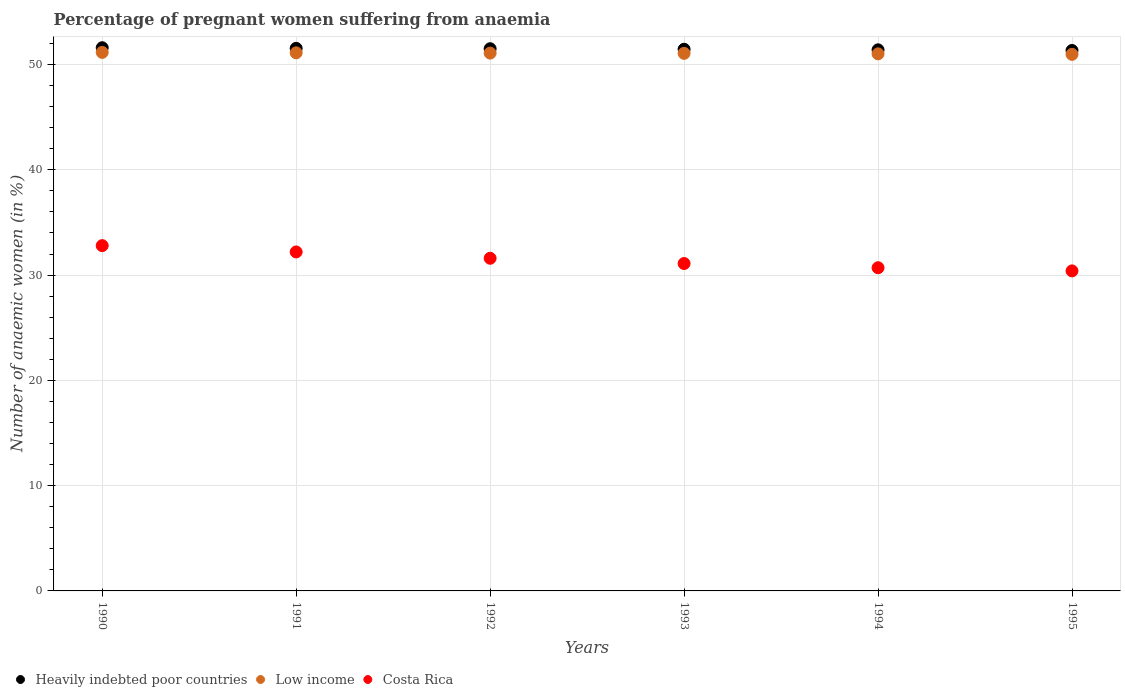How many different coloured dotlines are there?
Provide a short and direct response. 3. Is the number of dotlines equal to the number of legend labels?
Keep it short and to the point. Yes. What is the number of anaemic women in Low income in 1994?
Your answer should be very brief. 51.02. Across all years, what is the maximum number of anaemic women in Low income?
Offer a very short reply. 51.16. Across all years, what is the minimum number of anaemic women in Costa Rica?
Offer a terse response. 30.4. In which year was the number of anaemic women in Heavily indebted poor countries minimum?
Make the answer very short. 1995. What is the total number of anaemic women in Low income in the graph?
Ensure brevity in your answer.  306.41. What is the difference between the number of anaemic women in Heavily indebted poor countries in 1993 and that in 1995?
Offer a terse response. 0.12. What is the difference between the number of anaemic women in Heavily indebted poor countries in 1992 and the number of anaemic women in Costa Rica in 1990?
Give a very brief answer. 18.71. What is the average number of anaemic women in Low income per year?
Give a very brief answer. 51.07. In the year 1995, what is the difference between the number of anaemic women in Costa Rica and number of anaemic women in Heavily indebted poor countries?
Offer a terse response. -20.94. What is the ratio of the number of anaemic women in Heavily indebted poor countries in 1991 to that in 1992?
Your response must be concise. 1. Is the difference between the number of anaemic women in Costa Rica in 1991 and 1992 greater than the difference between the number of anaemic women in Heavily indebted poor countries in 1991 and 1992?
Ensure brevity in your answer.  Yes. What is the difference between the highest and the second highest number of anaemic women in Heavily indebted poor countries?
Ensure brevity in your answer.  0.06. What is the difference between the highest and the lowest number of anaemic women in Low income?
Offer a very short reply. 0.19. Is the sum of the number of anaemic women in Heavily indebted poor countries in 1990 and 1991 greater than the maximum number of anaemic women in Costa Rica across all years?
Make the answer very short. Yes. Is it the case that in every year, the sum of the number of anaemic women in Low income and number of anaemic women in Costa Rica  is greater than the number of anaemic women in Heavily indebted poor countries?
Offer a terse response. Yes. Does the number of anaemic women in Heavily indebted poor countries monotonically increase over the years?
Provide a succinct answer. No. What is the difference between two consecutive major ticks on the Y-axis?
Offer a terse response. 10. Are the values on the major ticks of Y-axis written in scientific E-notation?
Provide a short and direct response. No. How are the legend labels stacked?
Offer a very short reply. Horizontal. What is the title of the graph?
Provide a succinct answer. Percentage of pregnant women suffering from anaemia. Does "Cyprus" appear as one of the legend labels in the graph?
Your answer should be very brief. No. What is the label or title of the Y-axis?
Give a very brief answer. Number of anaemic women (in %). What is the Number of anaemic women (in %) of Heavily indebted poor countries in 1990?
Offer a very short reply. 51.6. What is the Number of anaemic women (in %) of Low income in 1990?
Provide a short and direct response. 51.16. What is the Number of anaemic women (in %) of Costa Rica in 1990?
Ensure brevity in your answer.  32.8. What is the Number of anaemic women (in %) of Heavily indebted poor countries in 1991?
Keep it short and to the point. 51.54. What is the Number of anaemic women (in %) of Low income in 1991?
Your response must be concise. 51.12. What is the Number of anaemic women (in %) in Costa Rica in 1991?
Your response must be concise. 32.2. What is the Number of anaemic women (in %) in Heavily indebted poor countries in 1992?
Make the answer very short. 51.51. What is the Number of anaemic women (in %) of Low income in 1992?
Your answer should be compact. 51.09. What is the Number of anaemic women (in %) of Costa Rica in 1992?
Your answer should be compact. 31.6. What is the Number of anaemic women (in %) of Heavily indebted poor countries in 1993?
Your answer should be very brief. 51.46. What is the Number of anaemic women (in %) in Low income in 1993?
Your answer should be very brief. 51.06. What is the Number of anaemic women (in %) in Costa Rica in 1993?
Provide a short and direct response. 31.1. What is the Number of anaemic women (in %) of Heavily indebted poor countries in 1994?
Ensure brevity in your answer.  51.4. What is the Number of anaemic women (in %) in Low income in 1994?
Offer a very short reply. 51.02. What is the Number of anaemic women (in %) of Costa Rica in 1994?
Give a very brief answer. 30.7. What is the Number of anaemic women (in %) of Heavily indebted poor countries in 1995?
Your answer should be very brief. 51.34. What is the Number of anaemic women (in %) of Low income in 1995?
Ensure brevity in your answer.  50.97. What is the Number of anaemic women (in %) in Costa Rica in 1995?
Your response must be concise. 30.4. Across all years, what is the maximum Number of anaemic women (in %) of Heavily indebted poor countries?
Ensure brevity in your answer.  51.6. Across all years, what is the maximum Number of anaemic women (in %) in Low income?
Make the answer very short. 51.16. Across all years, what is the maximum Number of anaemic women (in %) in Costa Rica?
Provide a succinct answer. 32.8. Across all years, what is the minimum Number of anaemic women (in %) in Heavily indebted poor countries?
Offer a very short reply. 51.34. Across all years, what is the minimum Number of anaemic women (in %) of Low income?
Give a very brief answer. 50.97. Across all years, what is the minimum Number of anaemic women (in %) in Costa Rica?
Give a very brief answer. 30.4. What is the total Number of anaemic women (in %) of Heavily indebted poor countries in the graph?
Your answer should be very brief. 308.84. What is the total Number of anaemic women (in %) in Low income in the graph?
Provide a succinct answer. 306.41. What is the total Number of anaemic women (in %) in Costa Rica in the graph?
Your response must be concise. 188.8. What is the difference between the Number of anaemic women (in %) in Heavily indebted poor countries in 1990 and that in 1991?
Provide a succinct answer. 0.06. What is the difference between the Number of anaemic women (in %) in Low income in 1990 and that in 1991?
Ensure brevity in your answer.  0.04. What is the difference between the Number of anaemic women (in %) of Heavily indebted poor countries in 1990 and that in 1992?
Offer a very short reply. 0.09. What is the difference between the Number of anaemic women (in %) in Low income in 1990 and that in 1992?
Your response must be concise. 0.07. What is the difference between the Number of anaemic women (in %) of Heavily indebted poor countries in 1990 and that in 1993?
Your answer should be very brief. 0.14. What is the difference between the Number of anaemic women (in %) of Low income in 1990 and that in 1993?
Ensure brevity in your answer.  0.09. What is the difference between the Number of anaemic women (in %) of Costa Rica in 1990 and that in 1993?
Your answer should be compact. 1.7. What is the difference between the Number of anaemic women (in %) in Heavily indebted poor countries in 1990 and that in 1994?
Make the answer very short. 0.2. What is the difference between the Number of anaemic women (in %) of Low income in 1990 and that in 1994?
Your answer should be very brief. 0.14. What is the difference between the Number of anaemic women (in %) in Heavily indebted poor countries in 1990 and that in 1995?
Provide a succinct answer. 0.26. What is the difference between the Number of anaemic women (in %) in Low income in 1990 and that in 1995?
Your answer should be compact. 0.19. What is the difference between the Number of anaemic women (in %) of Costa Rica in 1990 and that in 1995?
Offer a very short reply. 2.4. What is the difference between the Number of anaemic women (in %) in Heavily indebted poor countries in 1991 and that in 1992?
Provide a succinct answer. 0.04. What is the difference between the Number of anaemic women (in %) of Low income in 1991 and that in 1992?
Provide a short and direct response. 0.03. What is the difference between the Number of anaemic women (in %) of Costa Rica in 1991 and that in 1992?
Your answer should be compact. 0.6. What is the difference between the Number of anaemic women (in %) in Heavily indebted poor countries in 1991 and that in 1993?
Your answer should be compact. 0.09. What is the difference between the Number of anaemic women (in %) in Low income in 1991 and that in 1993?
Offer a terse response. 0.05. What is the difference between the Number of anaemic women (in %) in Heavily indebted poor countries in 1991 and that in 1994?
Provide a succinct answer. 0.14. What is the difference between the Number of anaemic women (in %) in Low income in 1991 and that in 1994?
Provide a succinct answer. 0.1. What is the difference between the Number of anaemic women (in %) in Heavily indebted poor countries in 1991 and that in 1995?
Your response must be concise. 0.2. What is the difference between the Number of anaemic women (in %) in Low income in 1991 and that in 1995?
Your answer should be very brief. 0.14. What is the difference between the Number of anaemic women (in %) of Costa Rica in 1991 and that in 1995?
Ensure brevity in your answer.  1.8. What is the difference between the Number of anaemic women (in %) of Heavily indebted poor countries in 1992 and that in 1993?
Keep it short and to the point. 0.05. What is the difference between the Number of anaemic women (in %) of Low income in 1992 and that in 1993?
Offer a terse response. 0.02. What is the difference between the Number of anaemic women (in %) in Heavily indebted poor countries in 1992 and that in 1994?
Keep it short and to the point. 0.11. What is the difference between the Number of anaemic women (in %) in Low income in 1992 and that in 1994?
Your answer should be very brief. 0.07. What is the difference between the Number of anaemic women (in %) in Costa Rica in 1992 and that in 1994?
Offer a very short reply. 0.9. What is the difference between the Number of anaemic women (in %) of Heavily indebted poor countries in 1992 and that in 1995?
Ensure brevity in your answer.  0.17. What is the difference between the Number of anaemic women (in %) of Low income in 1992 and that in 1995?
Make the answer very short. 0.12. What is the difference between the Number of anaemic women (in %) in Costa Rica in 1992 and that in 1995?
Your response must be concise. 1.2. What is the difference between the Number of anaemic women (in %) of Heavily indebted poor countries in 1993 and that in 1994?
Your answer should be compact. 0.06. What is the difference between the Number of anaemic women (in %) in Low income in 1993 and that in 1994?
Keep it short and to the point. 0.05. What is the difference between the Number of anaemic women (in %) in Heavily indebted poor countries in 1993 and that in 1995?
Your answer should be compact. 0.12. What is the difference between the Number of anaemic women (in %) in Low income in 1993 and that in 1995?
Your answer should be compact. 0.09. What is the difference between the Number of anaemic women (in %) of Costa Rica in 1993 and that in 1995?
Keep it short and to the point. 0.7. What is the difference between the Number of anaemic women (in %) of Heavily indebted poor countries in 1994 and that in 1995?
Keep it short and to the point. 0.06. What is the difference between the Number of anaemic women (in %) of Low income in 1994 and that in 1995?
Provide a short and direct response. 0.05. What is the difference between the Number of anaemic women (in %) of Heavily indebted poor countries in 1990 and the Number of anaemic women (in %) of Low income in 1991?
Ensure brevity in your answer.  0.48. What is the difference between the Number of anaemic women (in %) of Heavily indebted poor countries in 1990 and the Number of anaemic women (in %) of Costa Rica in 1991?
Your response must be concise. 19.4. What is the difference between the Number of anaemic women (in %) in Low income in 1990 and the Number of anaemic women (in %) in Costa Rica in 1991?
Keep it short and to the point. 18.96. What is the difference between the Number of anaemic women (in %) in Heavily indebted poor countries in 1990 and the Number of anaemic women (in %) in Low income in 1992?
Make the answer very short. 0.51. What is the difference between the Number of anaemic women (in %) of Heavily indebted poor countries in 1990 and the Number of anaemic women (in %) of Costa Rica in 1992?
Your answer should be very brief. 20. What is the difference between the Number of anaemic women (in %) of Low income in 1990 and the Number of anaemic women (in %) of Costa Rica in 1992?
Provide a short and direct response. 19.56. What is the difference between the Number of anaemic women (in %) of Heavily indebted poor countries in 1990 and the Number of anaemic women (in %) of Low income in 1993?
Your answer should be very brief. 0.53. What is the difference between the Number of anaemic women (in %) of Heavily indebted poor countries in 1990 and the Number of anaemic women (in %) of Costa Rica in 1993?
Keep it short and to the point. 20.5. What is the difference between the Number of anaemic women (in %) in Low income in 1990 and the Number of anaemic women (in %) in Costa Rica in 1993?
Keep it short and to the point. 20.06. What is the difference between the Number of anaemic women (in %) of Heavily indebted poor countries in 1990 and the Number of anaemic women (in %) of Low income in 1994?
Your response must be concise. 0.58. What is the difference between the Number of anaemic women (in %) of Heavily indebted poor countries in 1990 and the Number of anaemic women (in %) of Costa Rica in 1994?
Offer a terse response. 20.9. What is the difference between the Number of anaemic women (in %) of Low income in 1990 and the Number of anaemic women (in %) of Costa Rica in 1994?
Offer a terse response. 20.46. What is the difference between the Number of anaemic women (in %) of Heavily indebted poor countries in 1990 and the Number of anaemic women (in %) of Low income in 1995?
Provide a succinct answer. 0.63. What is the difference between the Number of anaemic women (in %) of Heavily indebted poor countries in 1990 and the Number of anaemic women (in %) of Costa Rica in 1995?
Your answer should be very brief. 21.2. What is the difference between the Number of anaemic women (in %) in Low income in 1990 and the Number of anaemic women (in %) in Costa Rica in 1995?
Provide a succinct answer. 20.76. What is the difference between the Number of anaemic women (in %) of Heavily indebted poor countries in 1991 and the Number of anaemic women (in %) of Low income in 1992?
Your response must be concise. 0.45. What is the difference between the Number of anaemic women (in %) in Heavily indebted poor countries in 1991 and the Number of anaemic women (in %) in Costa Rica in 1992?
Provide a succinct answer. 19.94. What is the difference between the Number of anaemic women (in %) of Low income in 1991 and the Number of anaemic women (in %) of Costa Rica in 1992?
Offer a very short reply. 19.52. What is the difference between the Number of anaemic women (in %) in Heavily indebted poor countries in 1991 and the Number of anaemic women (in %) in Low income in 1993?
Your response must be concise. 0.48. What is the difference between the Number of anaemic women (in %) of Heavily indebted poor countries in 1991 and the Number of anaemic women (in %) of Costa Rica in 1993?
Your answer should be very brief. 20.44. What is the difference between the Number of anaemic women (in %) in Low income in 1991 and the Number of anaemic women (in %) in Costa Rica in 1993?
Offer a terse response. 20.02. What is the difference between the Number of anaemic women (in %) of Heavily indebted poor countries in 1991 and the Number of anaemic women (in %) of Low income in 1994?
Ensure brevity in your answer.  0.52. What is the difference between the Number of anaemic women (in %) in Heavily indebted poor countries in 1991 and the Number of anaemic women (in %) in Costa Rica in 1994?
Offer a terse response. 20.84. What is the difference between the Number of anaemic women (in %) in Low income in 1991 and the Number of anaemic women (in %) in Costa Rica in 1994?
Make the answer very short. 20.42. What is the difference between the Number of anaemic women (in %) of Heavily indebted poor countries in 1991 and the Number of anaemic women (in %) of Low income in 1995?
Your answer should be compact. 0.57. What is the difference between the Number of anaemic women (in %) of Heavily indebted poor countries in 1991 and the Number of anaemic women (in %) of Costa Rica in 1995?
Your answer should be very brief. 21.14. What is the difference between the Number of anaemic women (in %) in Low income in 1991 and the Number of anaemic women (in %) in Costa Rica in 1995?
Make the answer very short. 20.72. What is the difference between the Number of anaemic women (in %) in Heavily indebted poor countries in 1992 and the Number of anaemic women (in %) in Low income in 1993?
Offer a very short reply. 0.44. What is the difference between the Number of anaemic women (in %) in Heavily indebted poor countries in 1992 and the Number of anaemic women (in %) in Costa Rica in 1993?
Offer a very short reply. 20.41. What is the difference between the Number of anaemic women (in %) in Low income in 1992 and the Number of anaemic women (in %) in Costa Rica in 1993?
Your answer should be very brief. 19.99. What is the difference between the Number of anaemic women (in %) of Heavily indebted poor countries in 1992 and the Number of anaemic women (in %) of Low income in 1994?
Your answer should be compact. 0.49. What is the difference between the Number of anaemic women (in %) in Heavily indebted poor countries in 1992 and the Number of anaemic women (in %) in Costa Rica in 1994?
Provide a succinct answer. 20.81. What is the difference between the Number of anaemic women (in %) of Low income in 1992 and the Number of anaemic women (in %) of Costa Rica in 1994?
Your answer should be compact. 20.39. What is the difference between the Number of anaemic women (in %) in Heavily indebted poor countries in 1992 and the Number of anaemic women (in %) in Low income in 1995?
Provide a short and direct response. 0.53. What is the difference between the Number of anaemic women (in %) of Heavily indebted poor countries in 1992 and the Number of anaemic women (in %) of Costa Rica in 1995?
Provide a short and direct response. 21.11. What is the difference between the Number of anaemic women (in %) in Low income in 1992 and the Number of anaemic women (in %) in Costa Rica in 1995?
Keep it short and to the point. 20.69. What is the difference between the Number of anaemic women (in %) of Heavily indebted poor countries in 1993 and the Number of anaemic women (in %) of Low income in 1994?
Ensure brevity in your answer.  0.44. What is the difference between the Number of anaemic women (in %) in Heavily indebted poor countries in 1993 and the Number of anaemic women (in %) in Costa Rica in 1994?
Make the answer very short. 20.76. What is the difference between the Number of anaemic women (in %) in Low income in 1993 and the Number of anaemic women (in %) in Costa Rica in 1994?
Your answer should be very brief. 20.36. What is the difference between the Number of anaemic women (in %) in Heavily indebted poor countries in 1993 and the Number of anaemic women (in %) in Low income in 1995?
Your response must be concise. 0.48. What is the difference between the Number of anaemic women (in %) of Heavily indebted poor countries in 1993 and the Number of anaemic women (in %) of Costa Rica in 1995?
Offer a terse response. 21.06. What is the difference between the Number of anaemic women (in %) of Low income in 1993 and the Number of anaemic women (in %) of Costa Rica in 1995?
Provide a succinct answer. 20.66. What is the difference between the Number of anaemic women (in %) in Heavily indebted poor countries in 1994 and the Number of anaemic women (in %) in Low income in 1995?
Give a very brief answer. 0.43. What is the difference between the Number of anaemic women (in %) in Heavily indebted poor countries in 1994 and the Number of anaemic women (in %) in Costa Rica in 1995?
Provide a short and direct response. 21. What is the difference between the Number of anaemic women (in %) in Low income in 1994 and the Number of anaemic women (in %) in Costa Rica in 1995?
Your response must be concise. 20.62. What is the average Number of anaemic women (in %) in Heavily indebted poor countries per year?
Keep it short and to the point. 51.47. What is the average Number of anaemic women (in %) in Low income per year?
Make the answer very short. 51.07. What is the average Number of anaemic women (in %) of Costa Rica per year?
Make the answer very short. 31.47. In the year 1990, what is the difference between the Number of anaemic women (in %) of Heavily indebted poor countries and Number of anaemic women (in %) of Low income?
Your answer should be compact. 0.44. In the year 1990, what is the difference between the Number of anaemic women (in %) of Heavily indebted poor countries and Number of anaemic women (in %) of Costa Rica?
Make the answer very short. 18.8. In the year 1990, what is the difference between the Number of anaemic women (in %) of Low income and Number of anaemic women (in %) of Costa Rica?
Provide a short and direct response. 18.36. In the year 1991, what is the difference between the Number of anaemic women (in %) of Heavily indebted poor countries and Number of anaemic women (in %) of Low income?
Provide a short and direct response. 0.43. In the year 1991, what is the difference between the Number of anaemic women (in %) in Heavily indebted poor countries and Number of anaemic women (in %) in Costa Rica?
Make the answer very short. 19.34. In the year 1991, what is the difference between the Number of anaemic women (in %) in Low income and Number of anaemic women (in %) in Costa Rica?
Your answer should be compact. 18.92. In the year 1992, what is the difference between the Number of anaemic women (in %) of Heavily indebted poor countries and Number of anaemic women (in %) of Low income?
Your answer should be compact. 0.42. In the year 1992, what is the difference between the Number of anaemic women (in %) of Heavily indebted poor countries and Number of anaemic women (in %) of Costa Rica?
Keep it short and to the point. 19.91. In the year 1992, what is the difference between the Number of anaemic women (in %) in Low income and Number of anaemic women (in %) in Costa Rica?
Ensure brevity in your answer.  19.49. In the year 1993, what is the difference between the Number of anaemic women (in %) of Heavily indebted poor countries and Number of anaemic women (in %) of Low income?
Give a very brief answer. 0.39. In the year 1993, what is the difference between the Number of anaemic women (in %) of Heavily indebted poor countries and Number of anaemic women (in %) of Costa Rica?
Offer a very short reply. 20.36. In the year 1993, what is the difference between the Number of anaemic women (in %) in Low income and Number of anaemic women (in %) in Costa Rica?
Provide a succinct answer. 19.96. In the year 1994, what is the difference between the Number of anaemic women (in %) of Heavily indebted poor countries and Number of anaemic women (in %) of Low income?
Provide a succinct answer. 0.38. In the year 1994, what is the difference between the Number of anaemic women (in %) of Heavily indebted poor countries and Number of anaemic women (in %) of Costa Rica?
Make the answer very short. 20.7. In the year 1994, what is the difference between the Number of anaemic women (in %) in Low income and Number of anaemic women (in %) in Costa Rica?
Provide a succinct answer. 20.32. In the year 1995, what is the difference between the Number of anaemic women (in %) of Heavily indebted poor countries and Number of anaemic women (in %) of Low income?
Offer a very short reply. 0.37. In the year 1995, what is the difference between the Number of anaemic women (in %) in Heavily indebted poor countries and Number of anaemic women (in %) in Costa Rica?
Your answer should be compact. 20.94. In the year 1995, what is the difference between the Number of anaemic women (in %) of Low income and Number of anaemic women (in %) of Costa Rica?
Your answer should be very brief. 20.57. What is the ratio of the Number of anaemic women (in %) of Low income in 1990 to that in 1991?
Make the answer very short. 1. What is the ratio of the Number of anaemic women (in %) of Costa Rica in 1990 to that in 1991?
Your answer should be compact. 1.02. What is the ratio of the Number of anaemic women (in %) in Costa Rica in 1990 to that in 1992?
Your answer should be compact. 1.04. What is the ratio of the Number of anaemic women (in %) of Costa Rica in 1990 to that in 1993?
Give a very brief answer. 1.05. What is the ratio of the Number of anaemic women (in %) of Heavily indebted poor countries in 1990 to that in 1994?
Offer a very short reply. 1. What is the ratio of the Number of anaemic women (in %) in Low income in 1990 to that in 1994?
Make the answer very short. 1. What is the ratio of the Number of anaemic women (in %) of Costa Rica in 1990 to that in 1994?
Make the answer very short. 1.07. What is the ratio of the Number of anaemic women (in %) in Heavily indebted poor countries in 1990 to that in 1995?
Your response must be concise. 1.01. What is the ratio of the Number of anaemic women (in %) of Costa Rica in 1990 to that in 1995?
Your answer should be compact. 1.08. What is the ratio of the Number of anaemic women (in %) of Heavily indebted poor countries in 1991 to that in 1992?
Keep it short and to the point. 1. What is the ratio of the Number of anaemic women (in %) in Low income in 1991 to that in 1992?
Ensure brevity in your answer.  1. What is the ratio of the Number of anaemic women (in %) in Costa Rica in 1991 to that in 1992?
Give a very brief answer. 1.02. What is the ratio of the Number of anaemic women (in %) in Low income in 1991 to that in 1993?
Offer a very short reply. 1. What is the ratio of the Number of anaemic women (in %) in Costa Rica in 1991 to that in 1993?
Make the answer very short. 1.04. What is the ratio of the Number of anaemic women (in %) of Low income in 1991 to that in 1994?
Offer a very short reply. 1. What is the ratio of the Number of anaemic women (in %) in Costa Rica in 1991 to that in 1994?
Your answer should be very brief. 1.05. What is the ratio of the Number of anaemic women (in %) in Heavily indebted poor countries in 1991 to that in 1995?
Your answer should be compact. 1. What is the ratio of the Number of anaemic women (in %) in Low income in 1991 to that in 1995?
Offer a very short reply. 1. What is the ratio of the Number of anaemic women (in %) of Costa Rica in 1991 to that in 1995?
Keep it short and to the point. 1.06. What is the ratio of the Number of anaemic women (in %) in Costa Rica in 1992 to that in 1993?
Provide a succinct answer. 1.02. What is the ratio of the Number of anaemic women (in %) of Heavily indebted poor countries in 1992 to that in 1994?
Your response must be concise. 1. What is the ratio of the Number of anaemic women (in %) of Low income in 1992 to that in 1994?
Offer a very short reply. 1. What is the ratio of the Number of anaemic women (in %) in Costa Rica in 1992 to that in 1994?
Give a very brief answer. 1.03. What is the ratio of the Number of anaemic women (in %) in Heavily indebted poor countries in 1992 to that in 1995?
Offer a very short reply. 1. What is the ratio of the Number of anaemic women (in %) in Costa Rica in 1992 to that in 1995?
Offer a terse response. 1.04. What is the ratio of the Number of anaemic women (in %) in Low income in 1993 to that in 1995?
Offer a terse response. 1. What is the ratio of the Number of anaemic women (in %) in Costa Rica in 1993 to that in 1995?
Provide a succinct answer. 1.02. What is the ratio of the Number of anaemic women (in %) in Heavily indebted poor countries in 1994 to that in 1995?
Give a very brief answer. 1. What is the ratio of the Number of anaemic women (in %) of Low income in 1994 to that in 1995?
Ensure brevity in your answer.  1. What is the ratio of the Number of anaemic women (in %) of Costa Rica in 1994 to that in 1995?
Offer a very short reply. 1.01. What is the difference between the highest and the second highest Number of anaemic women (in %) in Heavily indebted poor countries?
Offer a very short reply. 0.06. What is the difference between the highest and the second highest Number of anaemic women (in %) of Low income?
Your response must be concise. 0.04. What is the difference between the highest and the second highest Number of anaemic women (in %) of Costa Rica?
Your response must be concise. 0.6. What is the difference between the highest and the lowest Number of anaemic women (in %) of Heavily indebted poor countries?
Keep it short and to the point. 0.26. What is the difference between the highest and the lowest Number of anaemic women (in %) in Low income?
Provide a succinct answer. 0.19. 